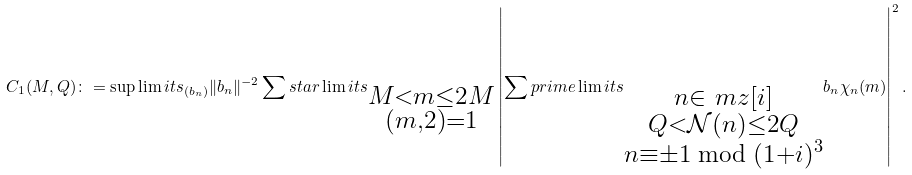Convert formula to latex. <formula><loc_0><loc_0><loc_500><loc_500>C _ { 1 } ( M , Q ) \colon = \sup \lim i t s _ { ( b _ { n } ) } \| b _ { n } \| ^ { - 2 } \sum s t a r \lim i t s _ { \substack { M < m \leq 2 M \\ ( m , 2 ) = 1 } } \left | \sum p r i m e \lim i t s _ { \substack { n \in \ m z [ i ] \\ Q < \mathcal { N } ( n ) \leq 2 Q \\ n \equiv \pm 1 \bmod { ( 1 + i ) ^ { 3 } } } } b _ { n } \chi _ { n } ( m ) \right | ^ { 2 } .</formula> 